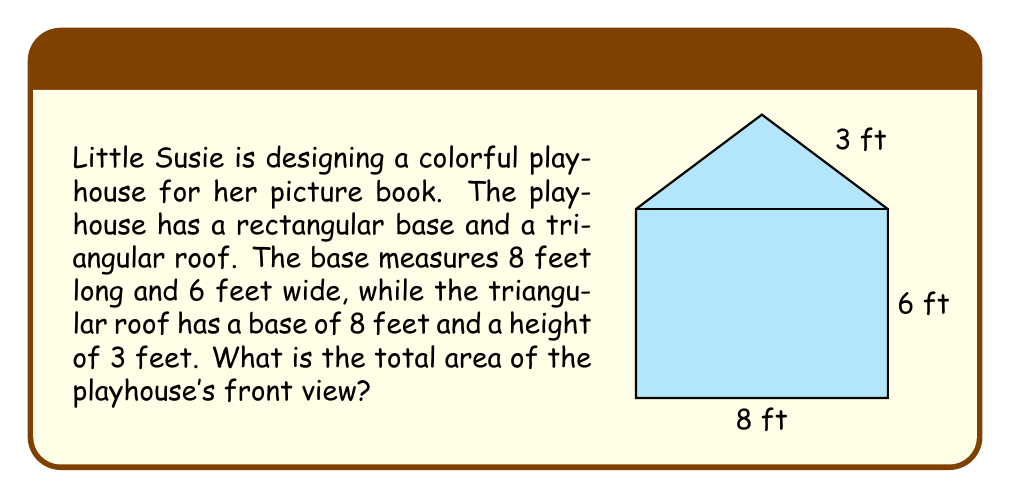Help me with this question. To solve this problem, we need to break it down into two parts: the rectangular base and the triangular roof. Let's calculate the area of each part separately and then add them together.

1. Area of the rectangular base:
   The formula for the area of a rectangle is $A = l \times w$, where $l$ is length and $w$ is width.
   $$A_{rectangle} = 8 \text{ ft} \times 6 \text{ ft} = 48 \text{ sq ft}$$

2. Area of the triangular roof:
   The formula for the area of a triangle is $A = \frac{1}{2} \times b \times h$, where $b$ is base and $h$ is height.
   $$A_{triangle} = \frac{1}{2} \times 8 \text{ ft} \times 3 \text{ ft} = 12 \text{ sq ft}$$

3. Total area of the playhouse's front view:
   To get the total area, we add the areas of the rectangle and triangle.
   $$A_{total} = A_{rectangle} + A_{triangle} = 48 \text{ sq ft} + 12 \text{ sq ft} = 60 \text{ sq ft}$$

Therefore, the total area of the playhouse's front view is 60 square feet.
Answer: 60 square feet 